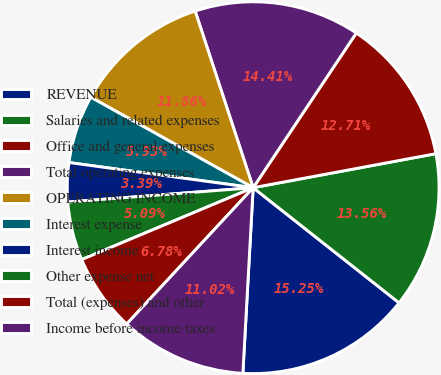Convert chart to OTSL. <chart><loc_0><loc_0><loc_500><loc_500><pie_chart><fcel>REVENUE<fcel>Salaries and related expenses<fcel>Office and general expenses<fcel>Total operating expenses<fcel>OPERATING INCOME<fcel>Interest expense<fcel>Interest income<fcel>Other expense net<fcel>Total (expenses) and other<fcel>Income before income taxes<nl><fcel>15.25%<fcel>13.56%<fcel>12.71%<fcel>14.41%<fcel>11.86%<fcel>5.93%<fcel>3.39%<fcel>5.09%<fcel>6.78%<fcel>11.02%<nl></chart> 